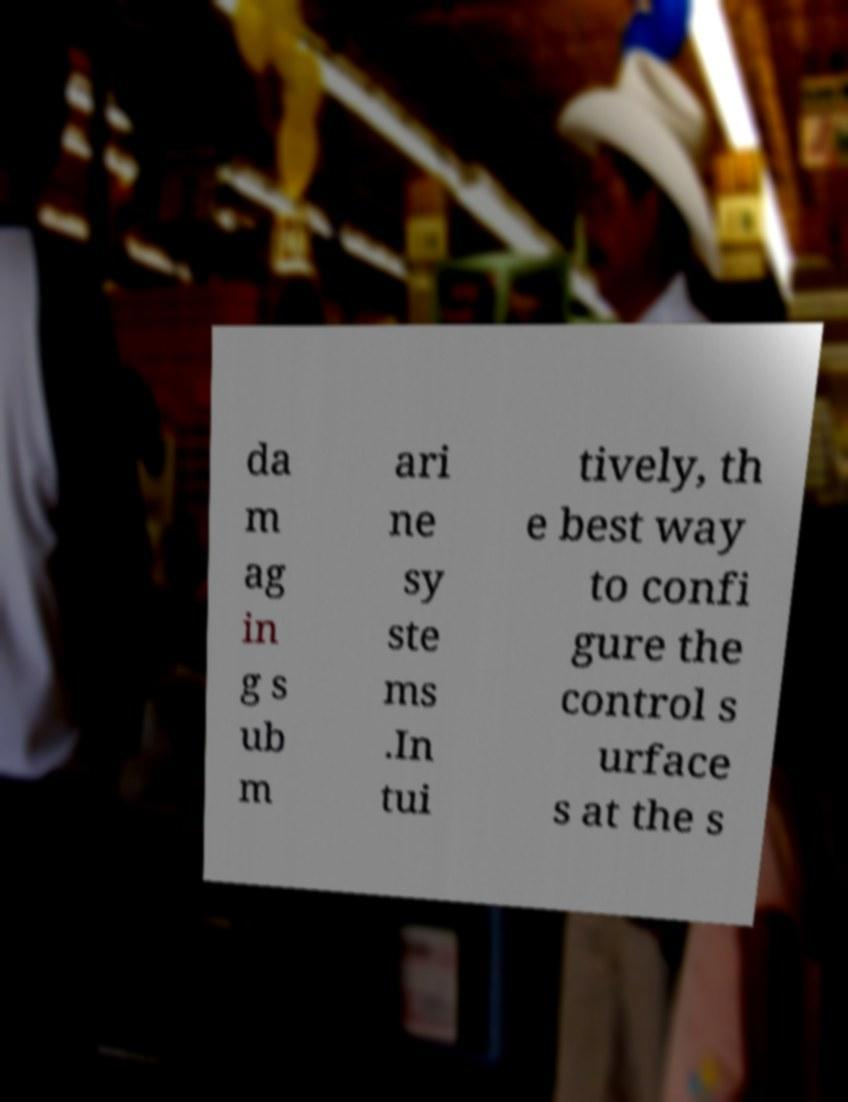For documentation purposes, I need the text within this image transcribed. Could you provide that? da m ag in g s ub m ari ne sy ste ms .In tui tively, th e best way to confi gure the control s urface s at the s 